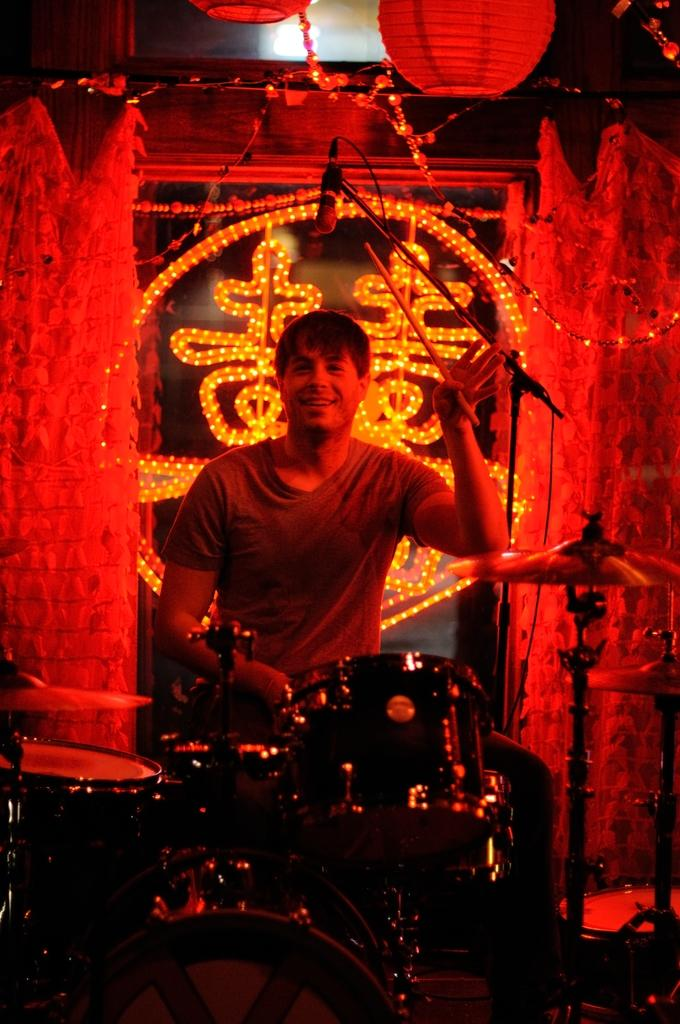What is the man in the image doing? The man is beating drums in the image. What type of clothing is the man wearing? The man is wearing a t-shirt in the image. What can be seen in the background of the image? There are lights visible in the image. What object is at the top of the image? There is a microphone at the top of the image. What type of suit is the man wearing in the image? The man is not wearing a suit in the image; he is wearing a t-shirt. How many errors can be seen in the image? There is no mention of errors in the image, so it cannot be determined how many there are. 